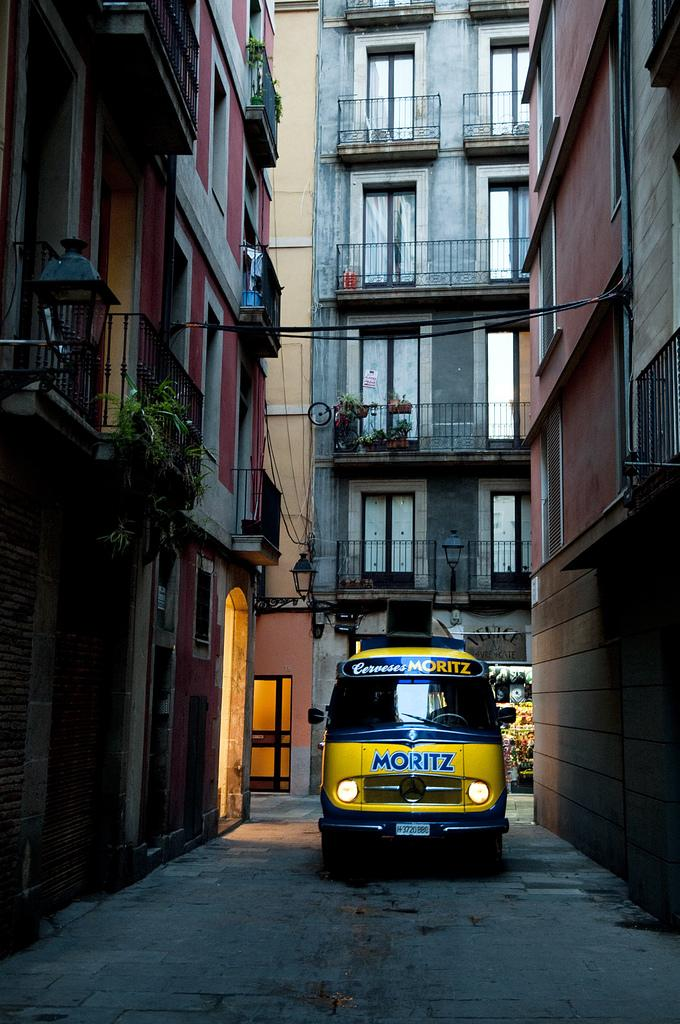What is the main feature of the image? There is a road in the image. What else can be seen on the road? There are vehicles in the image. What is the surrounding environment like? There are buildings surrounding the area in the image. What type of breakfast is being served in the image? There is no breakfast present in the image; it features a road with vehicles and buildings. 